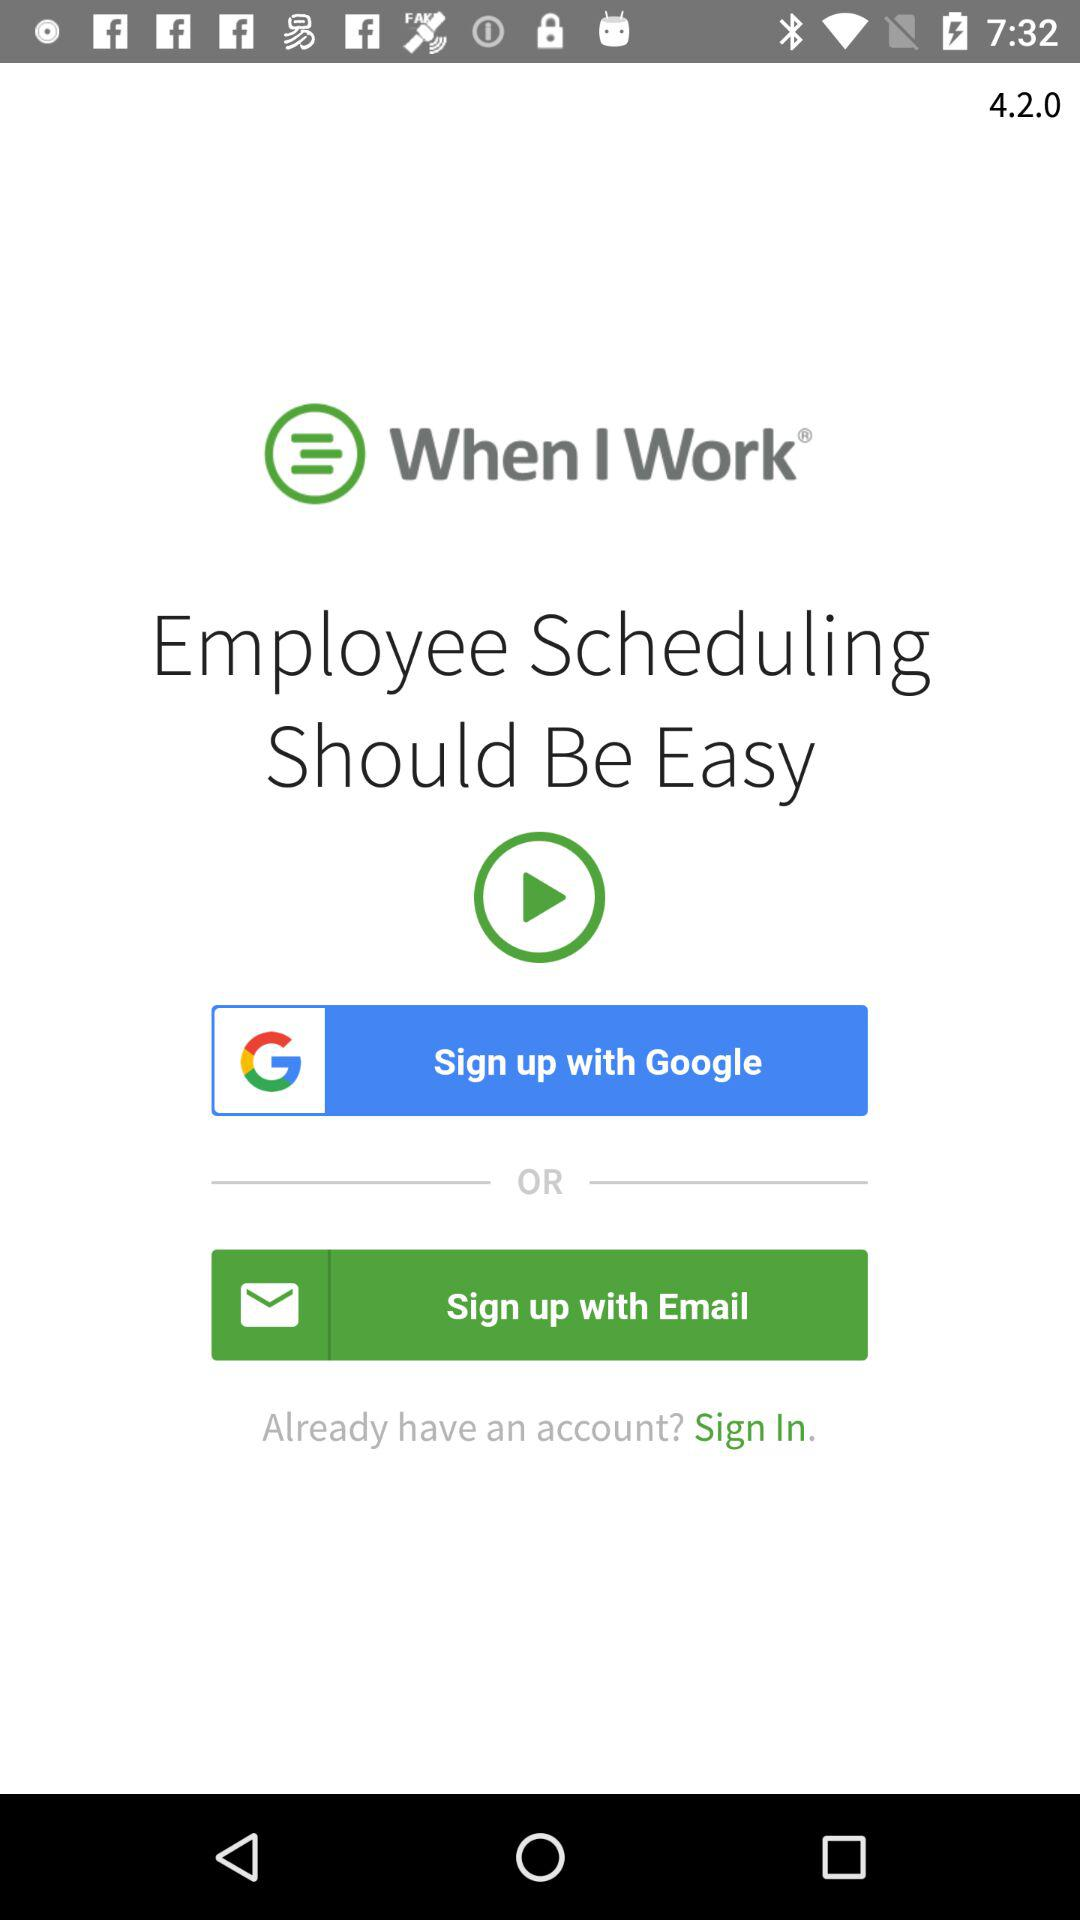What is the version of the application? The version of the application is 4.2.0. 